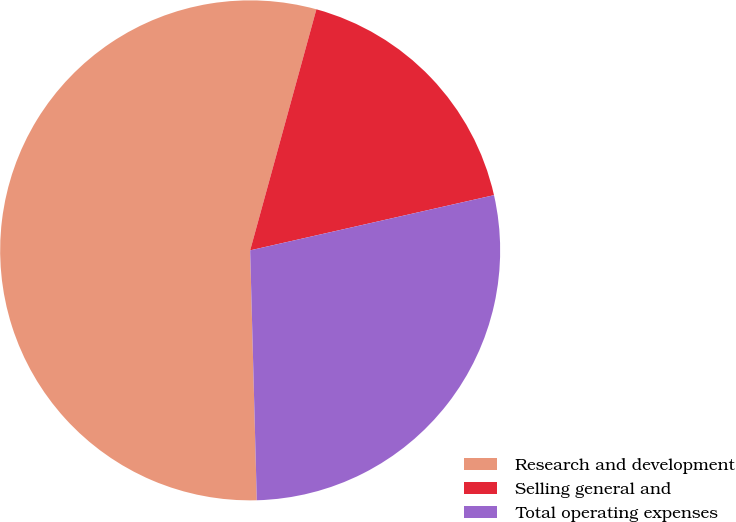Convert chart to OTSL. <chart><loc_0><loc_0><loc_500><loc_500><pie_chart><fcel>Research and development<fcel>Selling general and<fcel>Total operating expenses<nl><fcel>54.69%<fcel>17.19%<fcel>28.12%<nl></chart> 